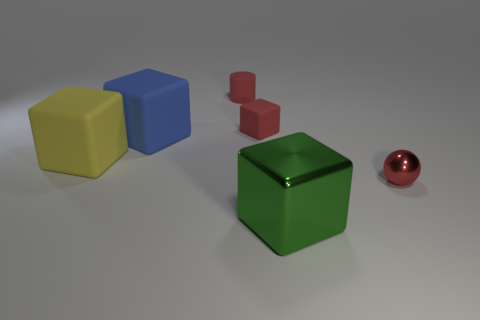Are there an equal number of big yellow blocks in front of the matte cylinder and objects?
Offer a terse response. No. Do the green thing and the red rubber block have the same size?
Your answer should be compact. No. There is a large block that is left of the red block and to the right of the yellow cube; what is its material?
Make the answer very short. Rubber. How many large blue rubber things have the same shape as the yellow matte object?
Offer a terse response. 1. What is the material of the object to the right of the green metal cube?
Keep it short and to the point. Metal. Are there fewer small red shiny objects behind the shiny ball than big gray spheres?
Keep it short and to the point. No. Is the big yellow rubber object the same shape as the large metallic object?
Offer a very short reply. Yes. Is there anything else that is the same shape as the big green metal thing?
Your response must be concise. Yes. Are there any tiny red cubes?
Your response must be concise. Yes. There is a big green metallic thing; is it the same shape as the shiny object behind the shiny block?
Offer a terse response. No. 